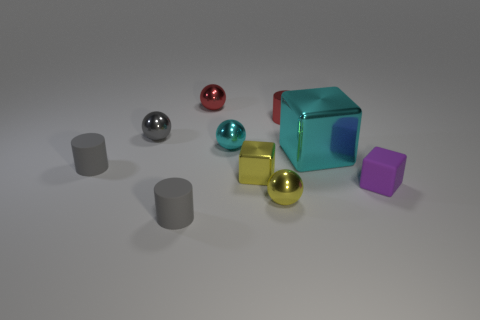Subtract all cyan balls. How many balls are left? 3 Subtract all red spheres. How many spheres are left? 3 Subtract all balls. How many objects are left? 6 Subtract 3 cubes. How many cubes are left? 0 Subtract all purple balls. Subtract all blue cubes. How many balls are left? 4 Subtract all big metallic cubes. Subtract all gray matte objects. How many objects are left? 7 Add 4 tiny gray things. How many tiny gray things are left? 7 Add 7 small rubber balls. How many small rubber balls exist? 7 Subtract 1 red cylinders. How many objects are left? 9 Subtract all purple cylinders. How many cyan spheres are left? 1 